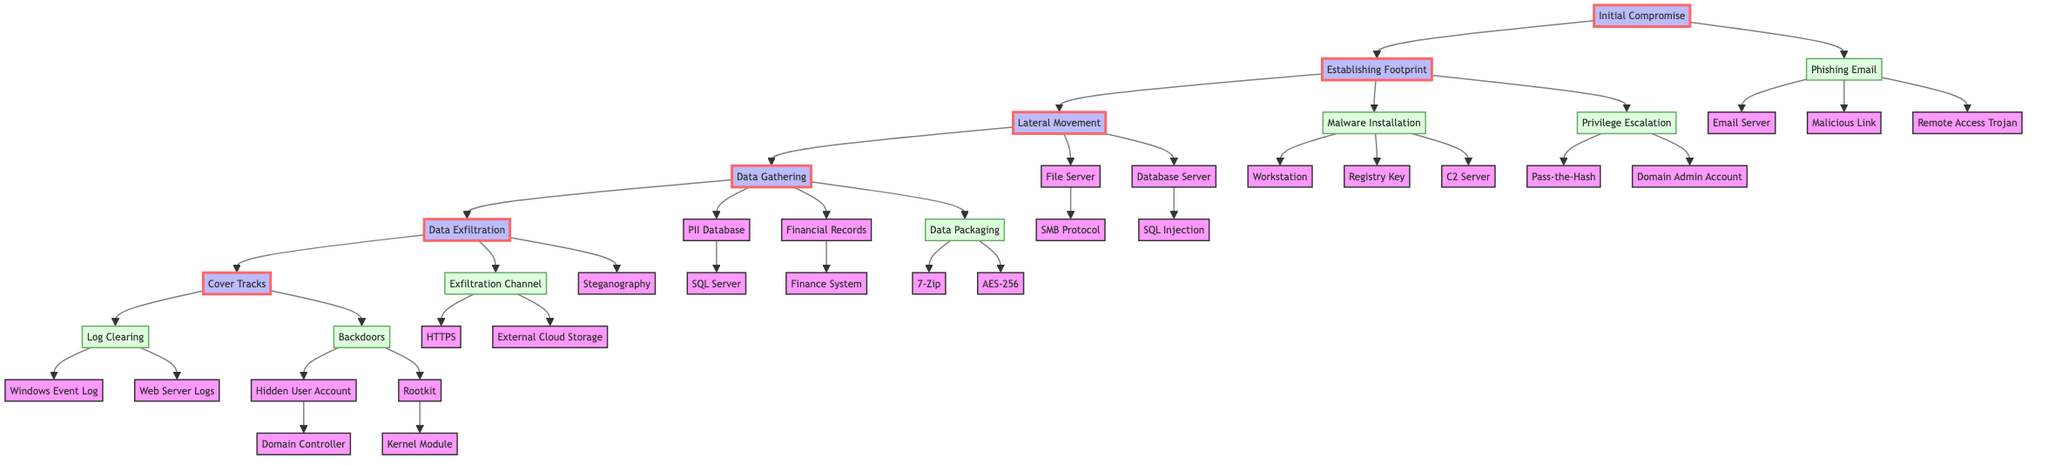What is the initial compromise method in the diagram? The initial compromise method is represented in the diagram as "Phishing Email," which is directly connected to the "Initial Compromise" phase.
Answer: Phishing Email How many systems are involved in the lateral movement phase? In the lateral movement phase, there are two types of compromised systems shown: "File Server" and "Database Server," indicating that the total is two systems involved.
Answer: 2 What protocol is used to access the file server? The file server is accessed using the "SMB Protocol," which is specified in the flow leading from "File Server" in the lateral movement phase.
Answer: SMB Protocol Which compression tool is mentioned for data packaging? The diagram specifies "7-Zip" as the compression tool used for data packaging, which is part of the data gathering process.
Answer: 7-Zip What method is used for privilege escalation? The privilege escalation technique noted in the flow chart is "Pass-the-Hash," which directly relates to how the attacker gains higher privileges in the system.
Answer: Pass-the-Hash What is the exfiltration destination in the last phase? The final phase of data exfiltration indicates that "External Cloud Storage (e.g., AWS S3)" is the destination for the stolen data being transferred out of the system.
Answer: External Cloud Storage Which log is targeted during the log clearing process? The targeted log mentioned in the log clearing process includes "Windows Event Log," showing the step to cover tracks after data exfiltration.
Answer: Windows Event Log What type of obfuscation technique is used in data exfiltration? The diagram details that "Steganography in Image Files" is the obfuscation technique used during the data exfiltration phase, hiding the data within images.
Answer: Steganography in Image Files How many backdoor types are shown in the cover tracks phase? There are two types of backdoors depicted in the cover tracks phase: "Hidden User Account" and "Rootkit," resulting in a total of two backdoor types shown.
Answer: 2 